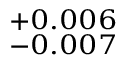<formula> <loc_0><loc_0><loc_500><loc_500>^ { + 0 . 0 0 6 } _ { - 0 . 0 0 7 }</formula> 